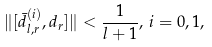Convert formula to latex. <formula><loc_0><loc_0><loc_500><loc_500>\| [ \bar { d } ^ { ( i ) } _ { l , r } , d _ { r } ] \| < \frac { 1 } { l + 1 } , \, i = 0 , 1 ,</formula> 